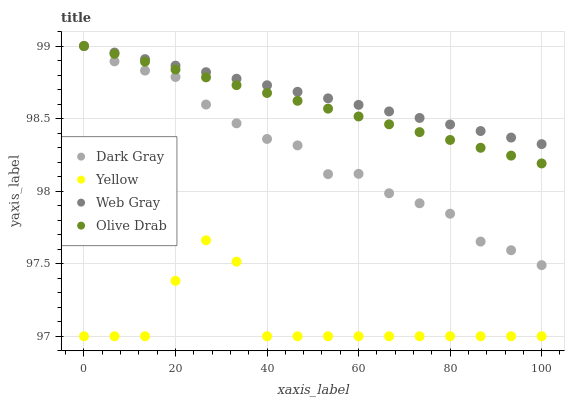Does Yellow have the minimum area under the curve?
Answer yes or no. Yes. Does Web Gray have the maximum area under the curve?
Answer yes or no. Yes. Does Olive Drab have the minimum area under the curve?
Answer yes or no. No. Does Olive Drab have the maximum area under the curve?
Answer yes or no. No. Is Web Gray the smoothest?
Answer yes or no. Yes. Is Yellow the roughest?
Answer yes or no. Yes. Is Olive Drab the smoothest?
Answer yes or no. No. Is Olive Drab the roughest?
Answer yes or no. No. Does Yellow have the lowest value?
Answer yes or no. Yes. Does Olive Drab have the lowest value?
Answer yes or no. No. Does Olive Drab have the highest value?
Answer yes or no. Yes. Does Yellow have the highest value?
Answer yes or no. No. Is Yellow less than Olive Drab?
Answer yes or no. Yes. Is Web Gray greater than Yellow?
Answer yes or no. Yes. Does Dark Gray intersect Olive Drab?
Answer yes or no. Yes. Is Dark Gray less than Olive Drab?
Answer yes or no. No. Is Dark Gray greater than Olive Drab?
Answer yes or no. No. Does Yellow intersect Olive Drab?
Answer yes or no. No. 